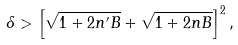Convert formula to latex. <formula><loc_0><loc_0><loc_500><loc_500>\delta > \left [ \sqrt { 1 + 2 n ^ { \prime } B } + \sqrt { 1 + 2 n B } \right ] ^ { 2 } ,</formula> 